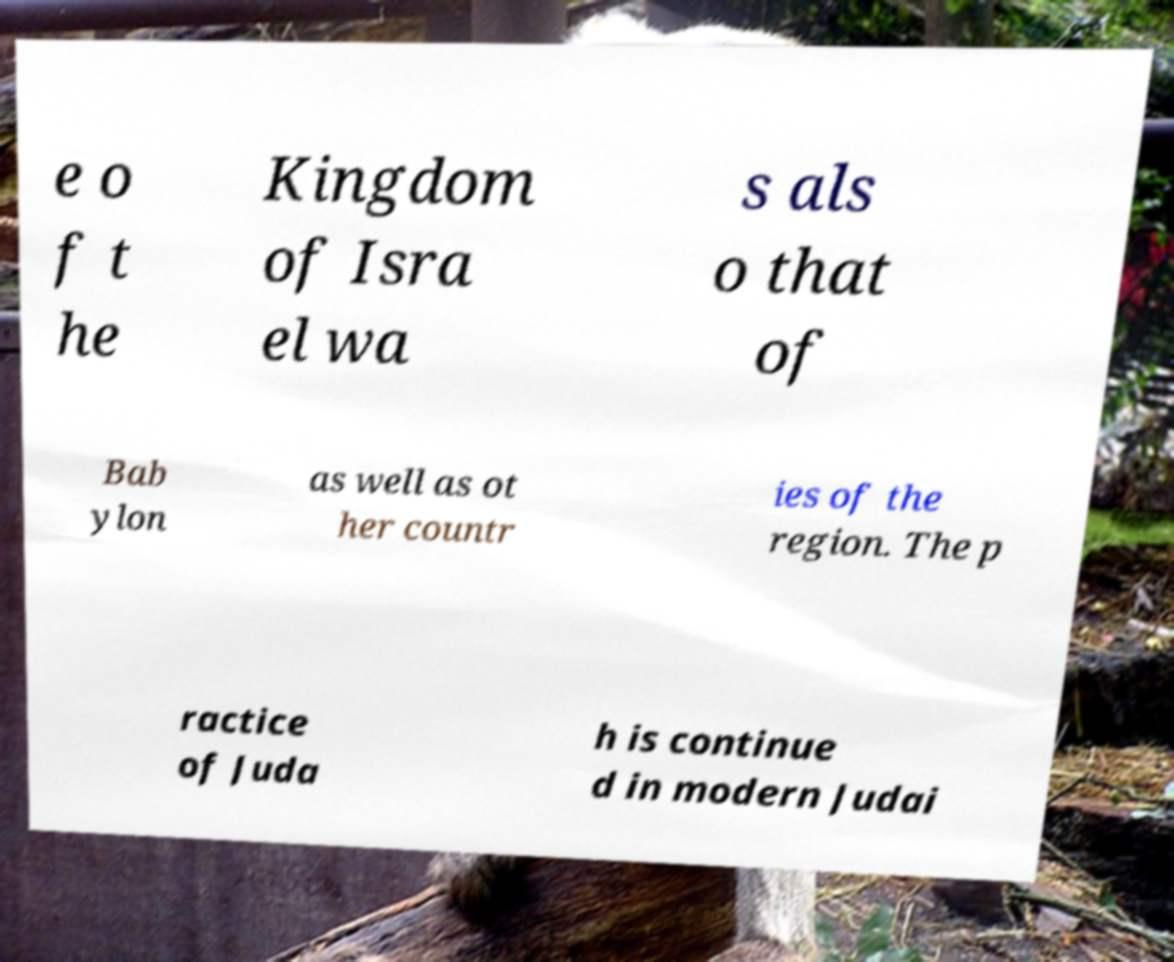Could you assist in decoding the text presented in this image and type it out clearly? e o f t he Kingdom of Isra el wa s als o that of Bab ylon as well as ot her countr ies of the region. The p ractice of Juda h is continue d in modern Judai 